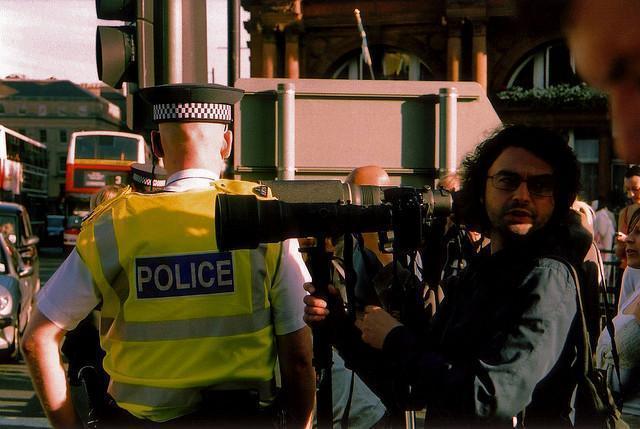What is the occupation of the man wearing a black coat?
Select the accurate response from the four choices given to answer the question.
Options: Policeman, photographer, film director, news reporter. News reporter. 